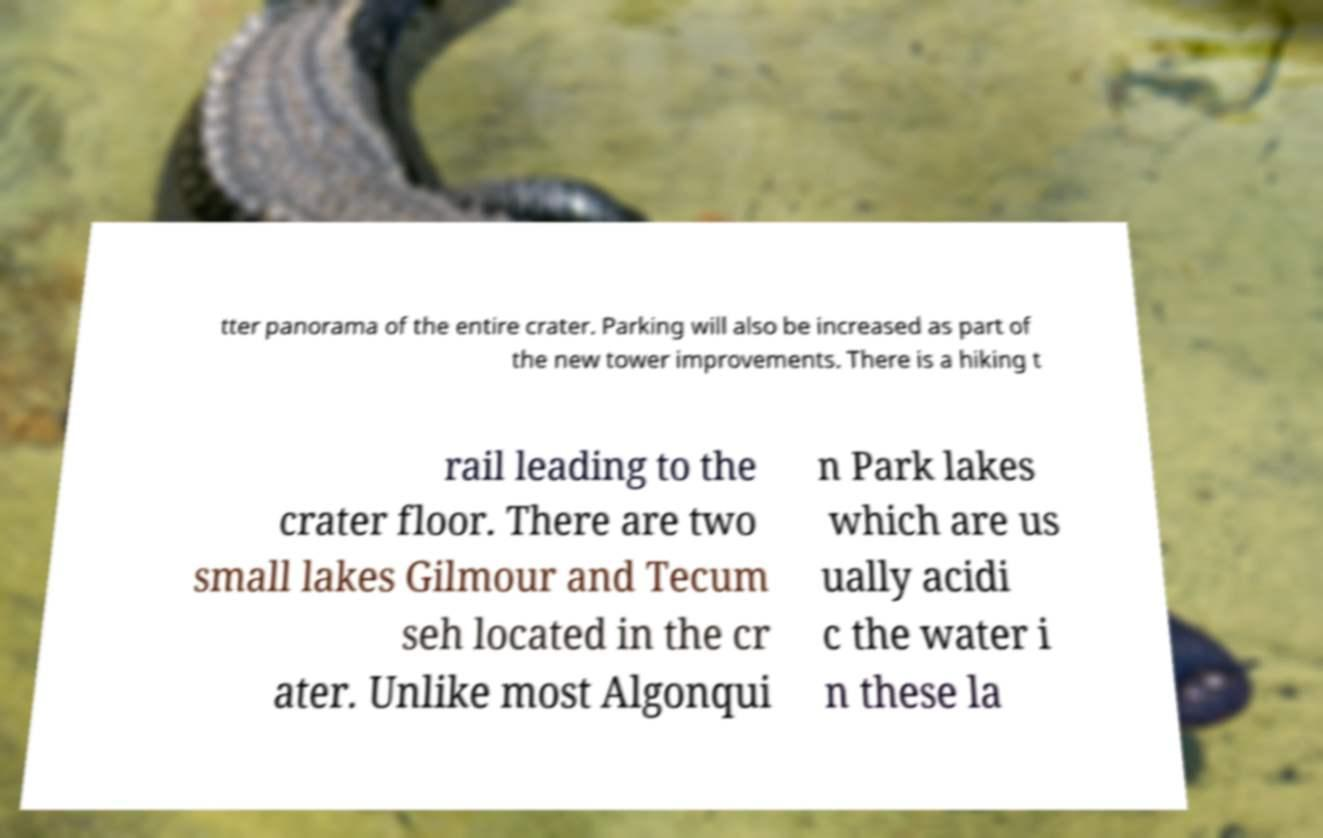Can you accurately transcribe the text from the provided image for me? tter panorama of the entire crater. Parking will also be increased as part of the new tower improvements. There is a hiking t rail leading to the crater floor. There are two small lakes Gilmour and Tecum seh located in the cr ater. Unlike most Algonqui n Park lakes which are us ually acidi c the water i n these la 